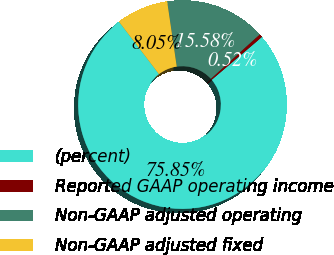Convert chart to OTSL. <chart><loc_0><loc_0><loc_500><loc_500><pie_chart><fcel>(percent)<fcel>Reported GAAP operating income<fcel>Non-GAAP adjusted operating<fcel>Non-GAAP adjusted fixed<nl><fcel>75.85%<fcel>0.52%<fcel>15.58%<fcel>8.05%<nl></chart> 